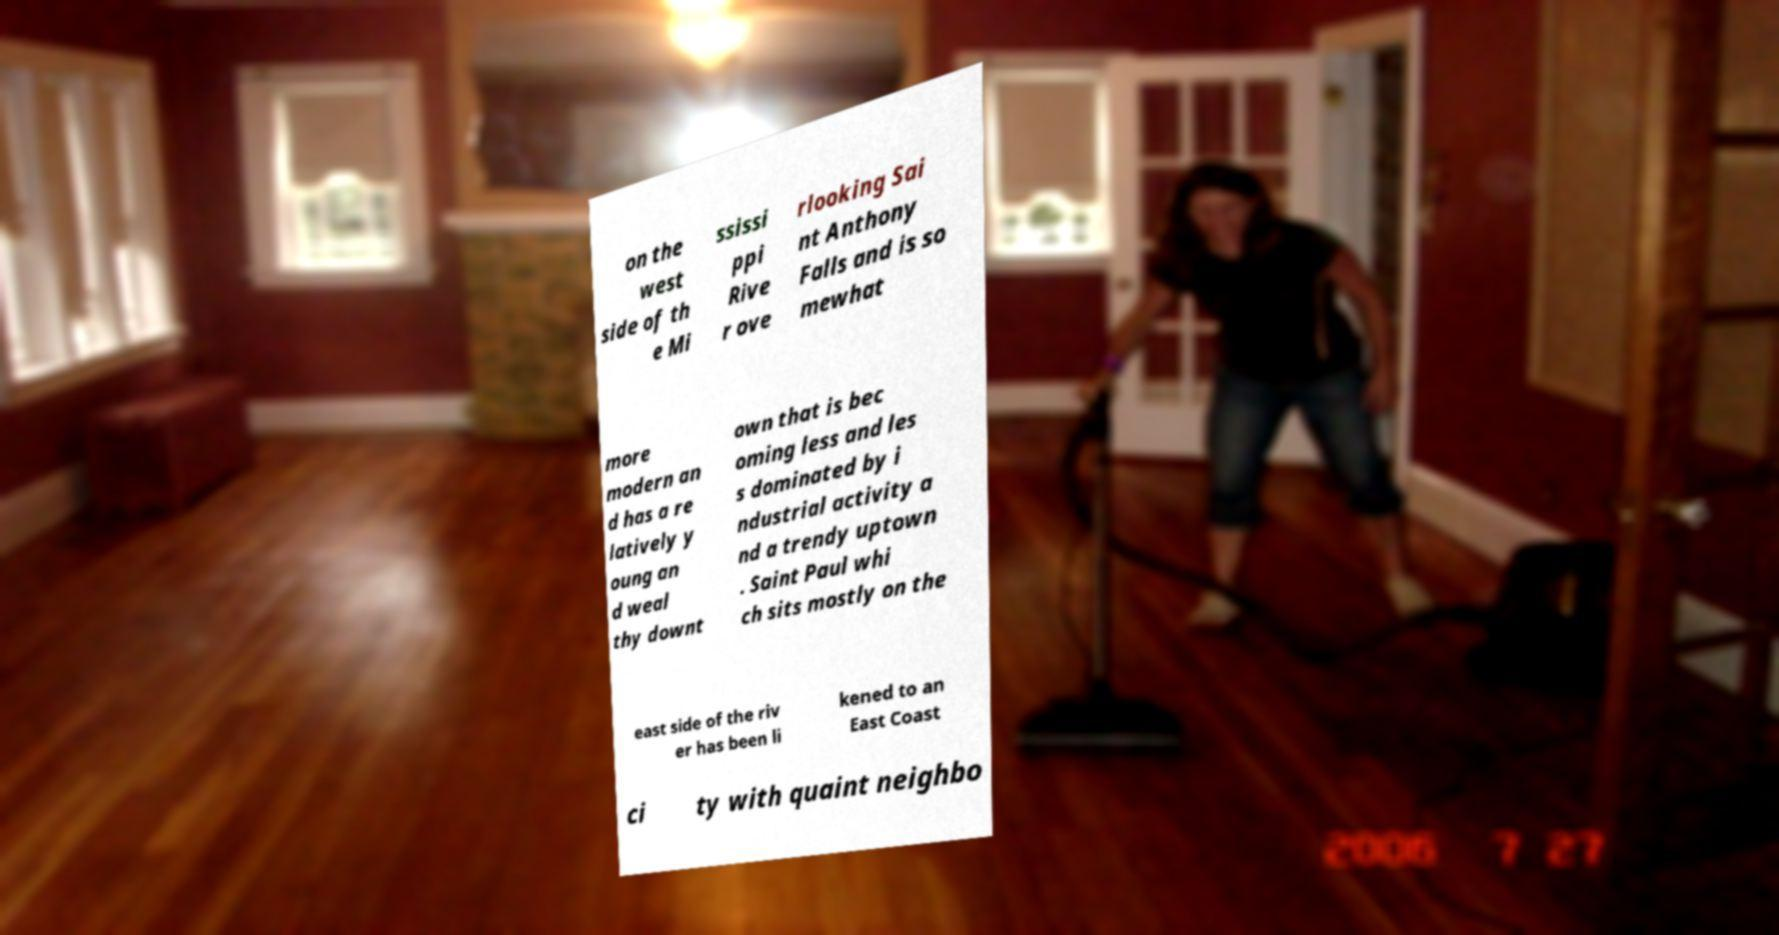Please read and relay the text visible in this image. What does it say? on the west side of th e Mi ssissi ppi Rive r ove rlooking Sai nt Anthony Falls and is so mewhat more modern an d has a re latively y oung an d weal thy downt own that is bec oming less and les s dominated by i ndustrial activity a nd a trendy uptown . Saint Paul whi ch sits mostly on the east side of the riv er has been li kened to an East Coast ci ty with quaint neighbo 